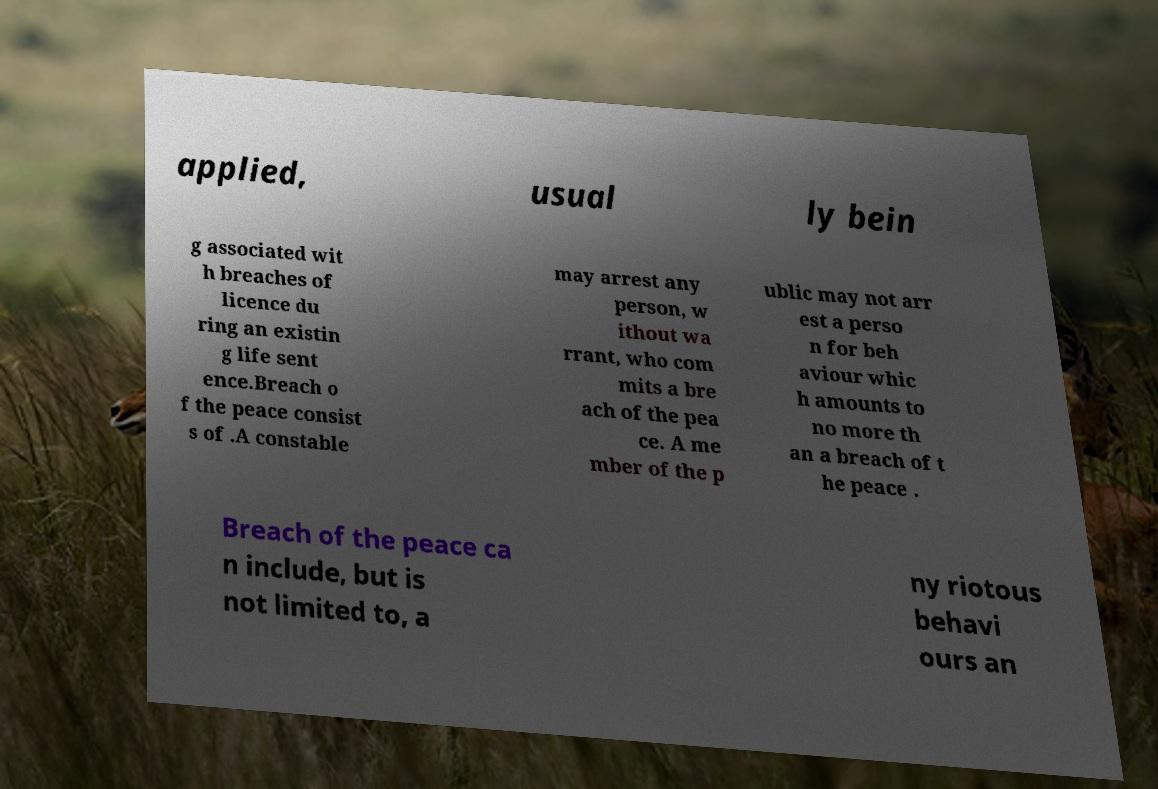For documentation purposes, I need the text within this image transcribed. Could you provide that? applied, usual ly bein g associated wit h breaches of licence du ring an existin g life sent ence.Breach o f the peace consist s of .A constable may arrest any person, w ithout wa rrant, who com mits a bre ach of the pea ce. A me mber of the p ublic may not arr est a perso n for beh aviour whic h amounts to no more th an a breach of t he peace . Breach of the peace ca n include, but is not limited to, a ny riotous behavi ours an 